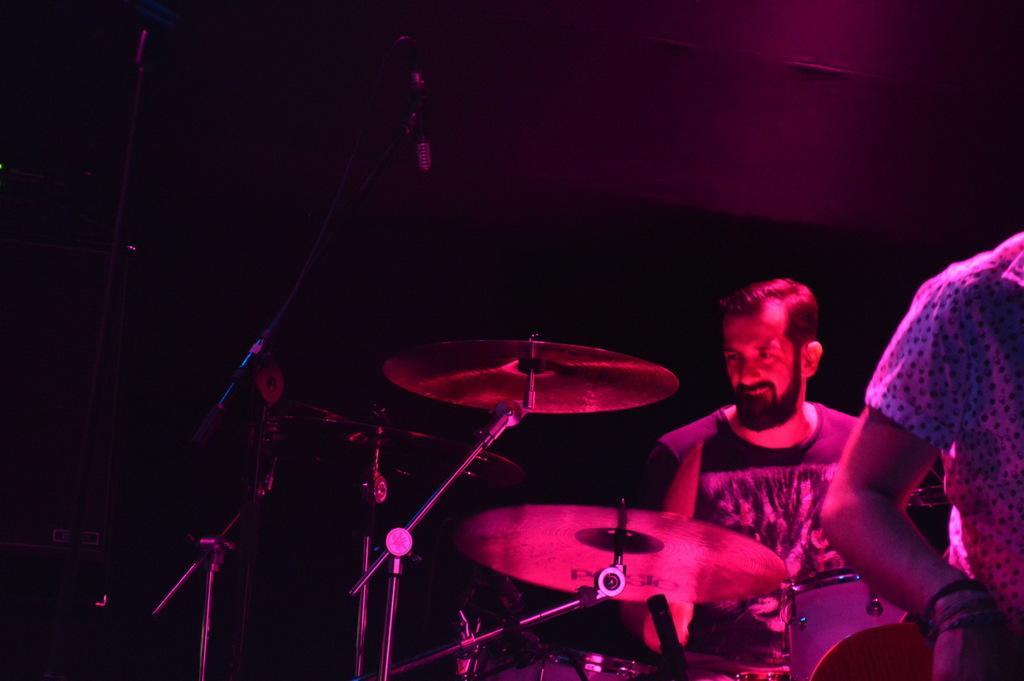How would you summarize this image in a sentence or two? In this picture we can see a man is sitting and in front of the man there are cymbals and stands and a person is standing. Behind the people there is a dark background. 